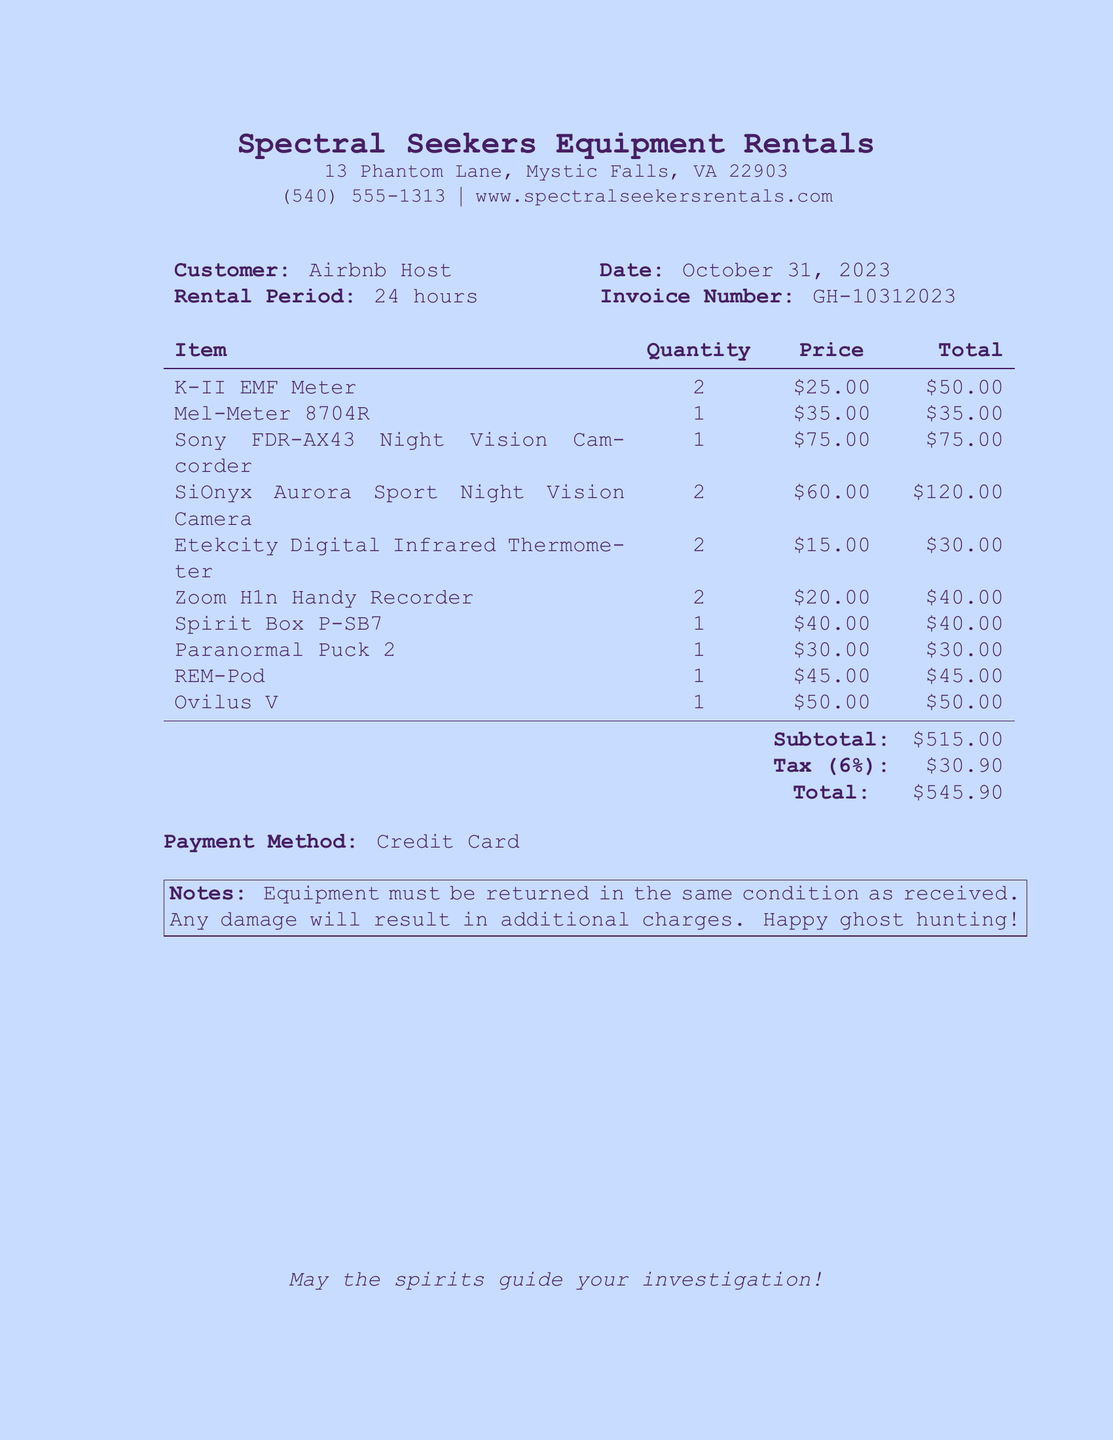What is the name of the business? The business name is listed at the top of the document.
Answer: Spectral Seekers Equipment Rentals What is the invoice number? The invoice number can be found under the customer information section.
Answer: GH-10312023 How many K-II EMF Meters were rented? The rental quantity for each item is specified in the document.
Answer: 2 What is the total amount due? The total amount is provided at the end of the itemized bill.
Answer: $545.90 What is the tax rate applied to the rental? The tax rate is mentioned in the subtotal section of the receipt.
Answer: 6% What equipment is recommended for ghost hunting? The receipt lists the rented items which are suitable for ghost hunting.
Answer: K-II EMF Meter, Mel-Meter 8704R, Sony FDR-AX43 Night Vision Camcorder, SiOnyx Aurora Sport Night Vision Camera, Etekcity Digital Infrared Thermometer, Zoom H1n Handy Recorder, Spirit Box P-SB7, Paranormal Puck 2, REM-Pod, Ovilus V What payment method was used? The payment method is specified towards the end of the document.
Answer: Credit Card What should the equipment be returned in? Instructions regarding the condition for returning equipment are included in the notes.
Answer: The same condition as received 